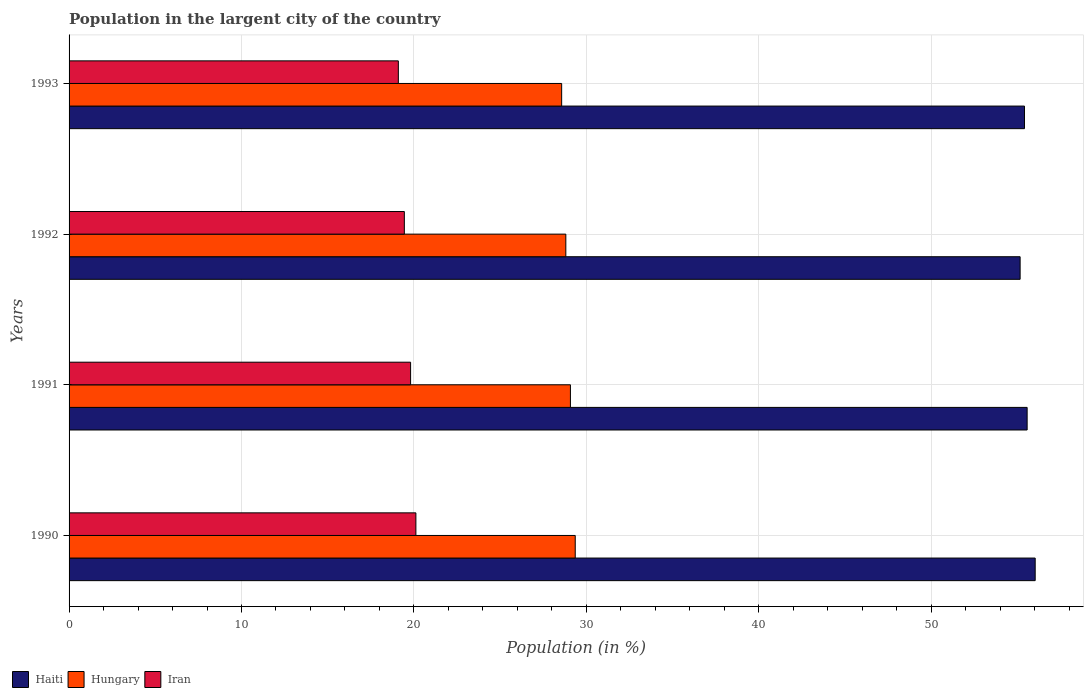Are the number of bars per tick equal to the number of legend labels?
Your answer should be compact. Yes. Are the number of bars on each tick of the Y-axis equal?
Give a very brief answer. Yes. What is the percentage of population in the largent city in Haiti in 1990?
Your answer should be compact. 56.04. Across all years, what is the maximum percentage of population in the largent city in Iran?
Ensure brevity in your answer.  20.12. Across all years, what is the minimum percentage of population in the largent city in Hungary?
Make the answer very short. 28.57. In which year was the percentage of population in the largent city in Iran maximum?
Provide a short and direct response. 1990. What is the total percentage of population in the largent city in Haiti in the graph?
Give a very brief answer. 222.19. What is the difference between the percentage of population in the largent city in Haiti in 1992 and that in 1993?
Keep it short and to the point. -0.25. What is the difference between the percentage of population in the largent city in Iran in 1990 and the percentage of population in the largent city in Hungary in 1991?
Offer a terse response. -8.96. What is the average percentage of population in the largent city in Haiti per year?
Provide a succinct answer. 55.55. In the year 1991, what is the difference between the percentage of population in the largent city in Hungary and percentage of population in the largent city in Haiti?
Your response must be concise. -26.49. What is the ratio of the percentage of population in the largent city in Iran in 1990 to that in 1992?
Make the answer very short. 1.03. Is the percentage of population in the largent city in Haiti in 1991 less than that in 1993?
Provide a succinct answer. No. What is the difference between the highest and the second highest percentage of population in the largent city in Haiti?
Make the answer very short. 0.47. What is the difference between the highest and the lowest percentage of population in the largent city in Hungary?
Make the answer very short. 0.79. Is the sum of the percentage of population in the largent city in Haiti in 1990 and 1992 greater than the maximum percentage of population in the largent city in Hungary across all years?
Give a very brief answer. Yes. What does the 3rd bar from the top in 1990 represents?
Offer a very short reply. Haiti. What does the 1st bar from the bottom in 1990 represents?
Offer a very short reply. Haiti. Is it the case that in every year, the sum of the percentage of population in the largent city in Iran and percentage of population in the largent city in Hungary is greater than the percentage of population in the largent city in Haiti?
Your answer should be very brief. No. How many bars are there?
Offer a terse response. 12. Are all the bars in the graph horizontal?
Your response must be concise. Yes. How are the legend labels stacked?
Make the answer very short. Horizontal. What is the title of the graph?
Offer a terse response. Population in the largent city of the country. What is the label or title of the X-axis?
Your response must be concise. Population (in %). What is the Population (in %) in Haiti in 1990?
Your answer should be compact. 56.04. What is the Population (in %) of Hungary in 1990?
Your answer should be compact. 29.36. What is the Population (in %) of Iran in 1990?
Offer a very short reply. 20.12. What is the Population (in %) of Haiti in 1991?
Your response must be concise. 55.57. What is the Population (in %) of Hungary in 1991?
Your answer should be compact. 29.08. What is the Population (in %) of Iran in 1991?
Give a very brief answer. 19.81. What is the Population (in %) in Haiti in 1992?
Ensure brevity in your answer.  55.16. What is the Population (in %) of Hungary in 1992?
Your answer should be very brief. 28.81. What is the Population (in %) in Iran in 1992?
Keep it short and to the point. 19.45. What is the Population (in %) of Haiti in 1993?
Your answer should be compact. 55.42. What is the Population (in %) of Hungary in 1993?
Make the answer very short. 28.57. What is the Population (in %) of Iran in 1993?
Offer a very short reply. 19.1. Across all years, what is the maximum Population (in %) in Haiti?
Provide a succinct answer. 56.04. Across all years, what is the maximum Population (in %) in Hungary?
Make the answer very short. 29.36. Across all years, what is the maximum Population (in %) of Iran?
Ensure brevity in your answer.  20.12. Across all years, what is the minimum Population (in %) of Haiti?
Your answer should be compact. 55.16. Across all years, what is the minimum Population (in %) in Hungary?
Provide a succinct answer. 28.57. Across all years, what is the minimum Population (in %) of Iran?
Your response must be concise. 19.1. What is the total Population (in %) in Haiti in the graph?
Provide a short and direct response. 222.19. What is the total Population (in %) of Hungary in the graph?
Keep it short and to the point. 115.82. What is the total Population (in %) in Iran in the graph?
Offer a very short reply. 78.47. What is the difference between the Population (in %) of Haiti in 1990 and that in 1991?
Give a very brief answer. 0.47. What is the difference between the Population (in %) in Hungary in 1990 and that in 1991?
Offer a very short reply. 0.28. What is the difference between the Population (in %) of Iran in 1990 and that in 1991?
Your answer should be compact. 0.31. What is the difference between the Population (in %) in Haiti in 1990 and that in 1992?
Give a very brief answer. 0.87. What is the difference between the Population (in %) of Hungary in 1990 and that in 1992?
Make the answer very short. 0.55. What is the difference between the Population (in %) of Iran in 1990 and that in 1992?
Offer a terse response. 0.67. What is the difference between the Population (in %) of Haiti in 1990 and that in 1993?
Your response must be concise. 0.62. What is the difference between the Population (in %) in Hungary in 1990 and that in 1993?
Provide a succinct answer. 0.79. What is the difference between the Population (in %) of Iran in 1990 and that in 1993?
Make the answer very short. 1.02. What is the difference between the Population (in %) in Haiti in 1991 and that in 1992?
Your response must be concise. 0.41. What is the difference between the Population (in %) of Hungary in 1991 and that in 1992?
Offer a very short reply. 0.27. What is the difference between the Population (in %) of Iran in 1991 and that in 1992?
Offer a very short reply. 0.36. What is the difference between the Population (in %) in Haiti in 1991 and that in 1993?
Make the answer very short. 0.15. What is the difference between the Population (in %) in Hungary in 1991 and that in 1993?
Ensure brevity in your answer.  0.51. What is the difference between the Population (in %) of Iran in 1991 and that in 1993?
Keep it short and to the point. 0.71. What is the difference between the Population (in %) of Haiti in 1992 and that in 1993?
Provide a succinct answer. -0.25. What is the difference between the Population (in %) of Hungary in 1992 and that in 1993?
Your answer should be very brief. 0.24. What is the difference between the Population (in %) of Iran in 1992 and that in 1993?
Keep it short and to the point. 0.35. What is the difference between the Population (in %) in Haiti in 1990 and the Population (in %) in Hungary in 1991?
Give a very brief answer. 26.96. What is the difference between the Population (in %) in Haiti in 1990 and the Population (in %) in Iran in 1991?
Give a very brief answer. 36.23. What is the difference between the Population (in %) of Hungary in 1990 and the Population (in %) of Iran in 1991?
Keep it short and to the point. 9.55. What is the difference between the Population (in %) in Haiti in 1990 and the Population (in %) in Hungary in 1992?
Offer a terse response. 27.22. What is the difference between the Population (in %) in Haiti in 1990 and the Population (in %) in Iran in 1992?
Your answer should be compact. 36.59. What is the difference between the Population (in %) in Hungary in 1990 and the Population (in %) in Iran in 1992?
Offer a terse response. 9.91. What is the difference between the Population (in %) of Haiti in 1990 and the Population (in %) of Hungary in 1993?
Keep it short and to the point. 27.47. What is the difference between the Population (in %) in Haiti in 1990 and the Population (in %) in Iran in 1993?
Provide a short and direct response. 36.94. What is the difference between the Population (in %) in Hungary in 1990 and the Population (in %) in Iran in 1993?
Ensure brevity in your answer.  10.26. What is the difference between the Population (in %) of Haiti in 1991 and the Population (in %) of Hungary in 1992?
Your answer should be compact. 26.76. What is the difference between the Population (in %) in Haiti in 1991 and the Population (in %) in Iran in 1992?
Ensure brevity in your answer.  36.12. What is the difference between the Population (in %) of Hungary in 1991 and the Population (in %) of Iran in 1992?
Provide a succinct answer. 9.63. What is the difference between the Population (in %) in Haiti in 1991 and the Population (in %) in Hungary in 1993?
Offer a terse response. 27. What is the difference between the Population (in %) in Haiti in 1991 and the Population (in %) in Iran in 1993?
Offer a very short reply. 36.47. What is the difference between the Population (in %) in Hungary in 1991 and the Population (in %) in Iran in 1993?
Your answer should be very brief. 9.98. What is the difference between the Population (in %) of Haiti in 1992 and the Population (in %) of Hungary in 1993?
Provide a succinct answer. 26.59. What is the difference between the Population (in %) in Haiti in 1992 and the Population (in %) in Iran in 1993?
Offer a terse response. 36.06. What is the difference between the Population (in %) in Hungary in 1992 and the Population (in %) in Iran in 1993?
Your response must be concise. 9.71. What is the average Population (in %) in Haiti per year?
Give a very brief answer. 55.55. What is the average Population (in %) of Hungary per year?
Make the answer very short. 28.96. What is the average Population (in %) in Iran per year?
Your answer should be very brief. 19.62. In the year 1990, what is the difference between the Population (in %) in Haiti and Population (in %) in Hungary?
Your answer should be compact. 26.68. In the year 1990, what is the difference between the Population (in %) of Haiti and Population (in %) of Iran?
Your response must be concise. 35.92. In the year 1990, what is the difference between the Population (in %) in Hungary and Population (in %) in Iran?
Keep it short and to the point. 9.24. In the year 1991, what is the difference between the Population (in %) in Haiti and Population (in %) in Hungary?
Offer a terse response. 26.49. In the year 1991, what is the difference between the Population (in %) in Haiti and Population (in %) in Iran?
Your response must be concise. 35.76. In the year 1991, what is the difference between the Population (in %) in Hungary and Population (in %) in Iran?
Offer a very short reply. 9.27. In the year 1992, what is the difference between the Population (in %) in Haiti and Population (in %) in Hungary?
Provide a short and direct response. 26.35. In the year 1992, what is the difference between the Population (in %) in Haiti and Population (in %) in Iran?
Provide a succinct answer. 35.72. In the year 1992, what is the difference between the Population (in %) of Hungary and Population (in %) of Iran?
Provide a short and direct response. 9.37. In the year 1993, what is the difference between the Population (in %) of Haiti and Population (in %) of Hungary?
Provide a short and direct response. 26.85. In the year 1993, what is the difference between the Population (in %) of Haiti and Population (in %) of Iran?
Ensure brevity in your answer.  36.32. In the year 1993, what is the difference between the Population (in %) of Hungary and Population (in %) of Iran?
Your response must be concise. 9.47. What is the ratio of the Population (in %) of Haiti in 1990 to that in 1991?
Provide a succinct answer. 1.01. What is the ratio of the Population (in %) of Hungary in 1990 to that in 1991?
Give a very brief answer. 1.01. What is the ratio of the Population (in %) in Iran in 1990 to that in 1991?
Your answer should be compact. 1.02. What is the ratio of the Population (in %) in Haiti in 1990 to that in 1992?
Your answer should be compact. 1.02. What is the ratio of the Population (in %) in Hungary in 1990 to that in 1992?
Provide a succinct answer. 1.02. What is the ratio of the Population (in %) in Iran in 1990 to that in 1992?
Provide a succinct answer. 1.03. What is the ratio of the Population (in %) of Haiti in 1990 to that in 1993?
Offer a terse response. 1.01. What is the ratio of the Population (in %) of Hungary in 1990 to that in 1993?
Your response must be concise. 1.03. What is the ratio of the Population (in %) in Iran in 1990 to that in 1993?
Your answer should be compact. 1.05. What is the ratio of the Population (in %) of Haiti in 1991 to that in 1992?
Make the answer very short. 1.01. What is the ratio of the Population (in %) in Hungary in 1991 to that in 1992?
Offer a terse response. 1.01. What is the ratio of the Population (in %) in Iran in 1991 to that in 1992?
Your answer should be compact. 1.02. What is the ratio of the Population (in %) in Hungary in 1991 to that in 1993?
Your answer should be compact. 1.02. What is the ratio of the Population (in %) in Iran in 1991 to that in 1993?
Keep it short and to the point. 1.04. What is the ratio of the Population (in %) in Hungary in 1992 to that in 1993?
Keep it short and to the point. 1.01. What is the ratio of the Population (in %) in Iran in 1992 to that in 1993?
Give a very brief answer. 1.02. What is the difference between the highest and the second highest Population (in %) of Haiti?
Provide a short and direct response. 0.47. What is the difference between the highest and the second highest Population (in %) of Hungary?
Make the answer very short. 0.28. What is the difference between the highest and the second highest Population (in %) of Iran?
Make the answer very short. 0.31. What is the difference between the highest and the lowest Population (in %) of Haiti?
Make the answer very short. 0.87. What is the difference between the highest and the lowest Population (in %) in Hungary?
Your answer should be compact. 0.79. What is the difference between the highest and the lowest Population (in %) of Iran?
Your response must be concise. 1.02. 